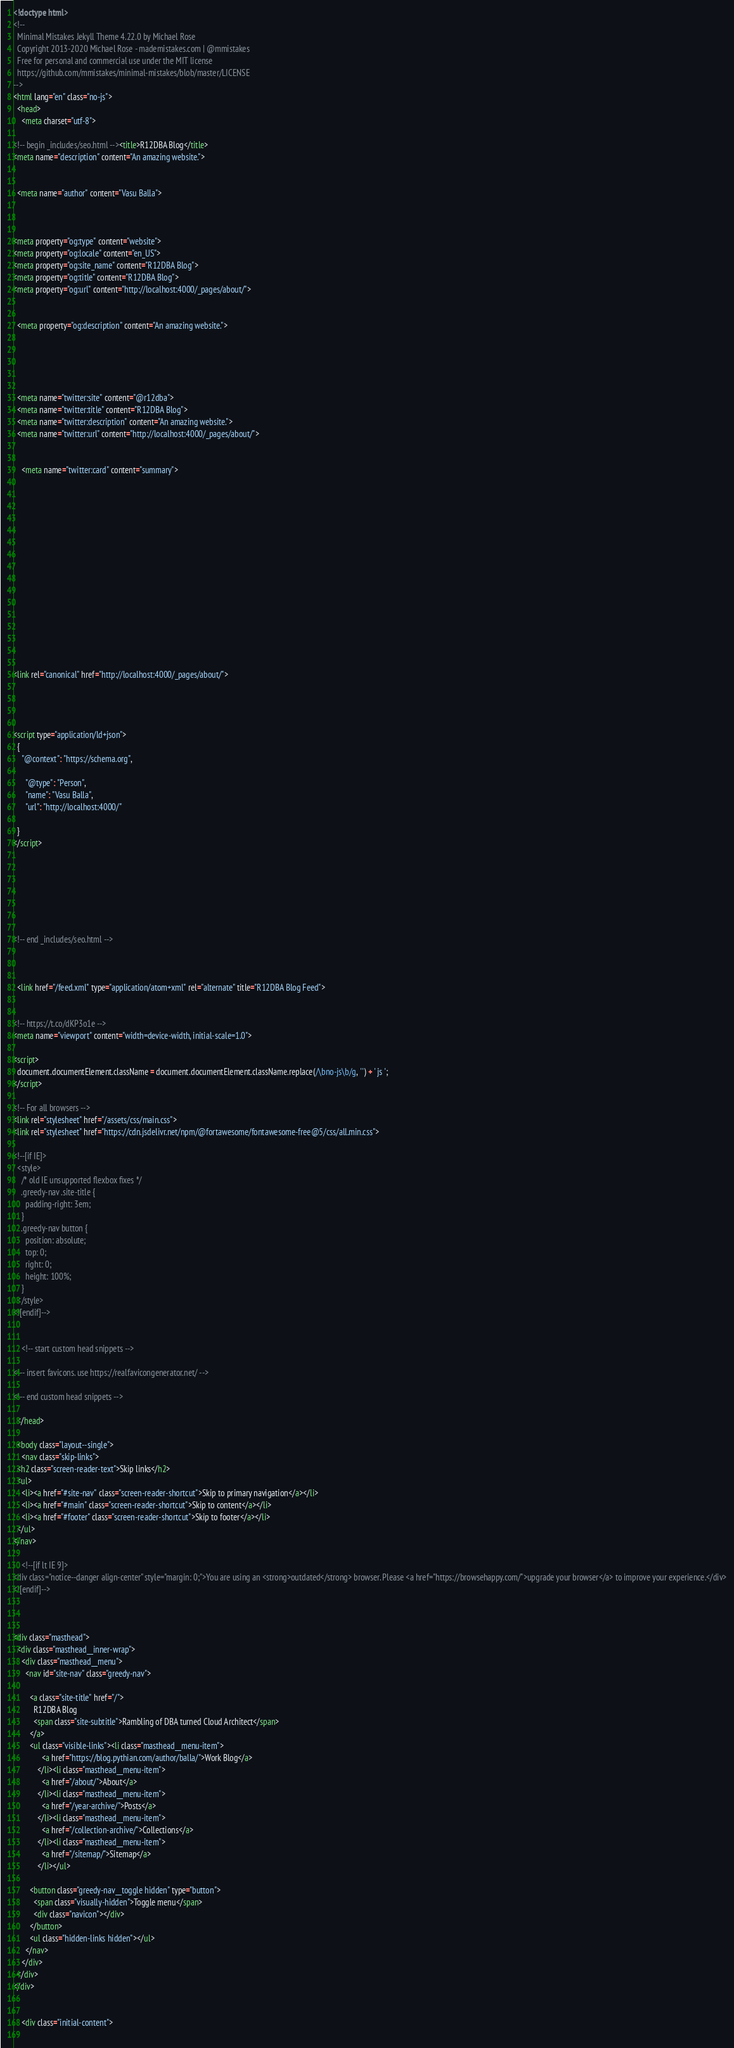<code> <loc_0><loc_0><loc_500><loc_500><_HTML_><!doctype html>
<!--
  Minimal Mistakes Jekyll Theme 4.22.0 by Michael Rose
  Copyright 2013-2020 Michael Rose - mademistakes.com | @mmistakes
  Free for personal and commercial use under the MIT license
  https://github.com/mmistakes/minimal-mistakes/blob/master/LICENSE
-->
<html lang="en" class="no-js">
  <head>
    <meta charset="utf-8">

<!-- begin _includes/seo.html --><title>R12DBA Blog</title>
<meta name="description" content="An amazing website.">


  <meta name="author" content="Vasu Balla">
  


<meta property="og:type" content="website">
<meta property="og:locale" content="en_US">
<meta property="og:site_name" content="R12DBA Blog">
<meta property="og:title" content="R12DBA Blog">
<meta property="og:url" content="http://localhost:4000/_pages/about/">


  <meta property="og:description" content="An amazing website.">





  <meta name="twitter:site" content="@r12dba">
  <meta name="twitter:title" content="R12DBA Blog">
  <meta name="twitter:description" content="An amazing website.">
  <meta name="twitter:url" content="http://localhost:4000/_pages/about/">

  
    <meta name="twitter:card" content="summary">
    
  

  







  

  


<link rel="canonical" href="http://localhost:4000/_pages/about/">




<script type="application/ld+json">
  {
    "@context": "https://schema.org",
    
      "@type": "Person",
      "name": "Vasu Balla",
      "url": "http://localhost:4000/"
    
  }
</script>







<!-- end _includes/seo.html -->



  <link href="/feed.xml" type="application/atom+xml" rel="alternate" title="R12DBA Blog Feed">


<!-- https://t.co/dKP3o1e -->
<meta name="viewport" content="width=device-width, initial-scale=1.0">

<script>
  document.documentElement.className = document.documentElement.className.replace(/\bno-js\b/g, '') + ' js ';
</script>

<!-- For all browsers -->
<link rel="stylesheet" href="/assets/css/main.css">
<link rel="stylesheet" href="https://cdn.jsdelivr.net/npm/@fortawesome/fontawesome-free@5/css/all.min.css">

<!--[if IE]>
  <style>
    /* old IE unsupported flexbox fixes */
    .greedy-nav .site-title {
      padding-right: 3em;
    }
    .greedy-nav button {
      position: absolute;
      top: 0;
      right: 0;
      height: 100%;
    }
  </style>
<![endif]-->


    <!-- start custom head snippets -->

<!-- insert favicons. use https://realfavicongenerator.net/ -->

<!-- end custom head snippets -->

  </head>

  <body class="layout--single">
    <nav class="skip-links">
  <h2 class="screen-reader-text">Skip links</h2>
  <ul>
    <li><a href="#site-nav" class="screen-reader-shortcut">Skip to primary navigation</a></li>
    <li><a href="#main" class="screen-reader-shortcut">Skip to content</a></li>
    <li><a href="#footer" class="screen-reader-shortcut">Skip to footer</a></li>
  </ul>
</nav>

    <!--[if lt IE 9]>
<div class="notice--danger align-center" style="margin: 0;">You are using an <strong>outdated</strong> browser. Please <a href="https://browsehappy.com/">upgrade your browser</a> to improve your experience.</div>
<![endif]-->

    

<div class="masthead">
  <div class="masthead__inner-wrap">
    <div class="masthead__menu">
      <nav id="site-nav" class="greedy-nav">
        
        <a class="site-title" href="/">
          R12DBA Blog
          <span class="site-subtitle">Rambling of DBA turned Cloud Architect</span>
        </a>
        <ul class="visible-links"><li class="masthead__menu-item">
              <a href="https://blog.pythian.com/author/balla/">Work Blog</a>
            </li><li class="masthead__menu-item">
              <a href="/about/">About</a>
            </li><li class="masthead__menu-item">
              <a href="/year-archive/">Posts</a>
            </li><li class="masthead__menu-item">
              <a href="/collection-archive/">Collections</a>
            </li><li class="masthead__menu-item">
              <a href="/sitemap/">Sitemap</a>
            </li></ul>
        
        <button class="greedy-nav__toggle hidden" type="button">
          <span class="visually-hidden">Toggle menu</span>
          <div class="navicon"></div>
        </button>
        <ul class="hidden-links hidden"></ul>
      </nav>
    </div>
  </div>
</div>


    <div class="initial-content">
      


</code> 